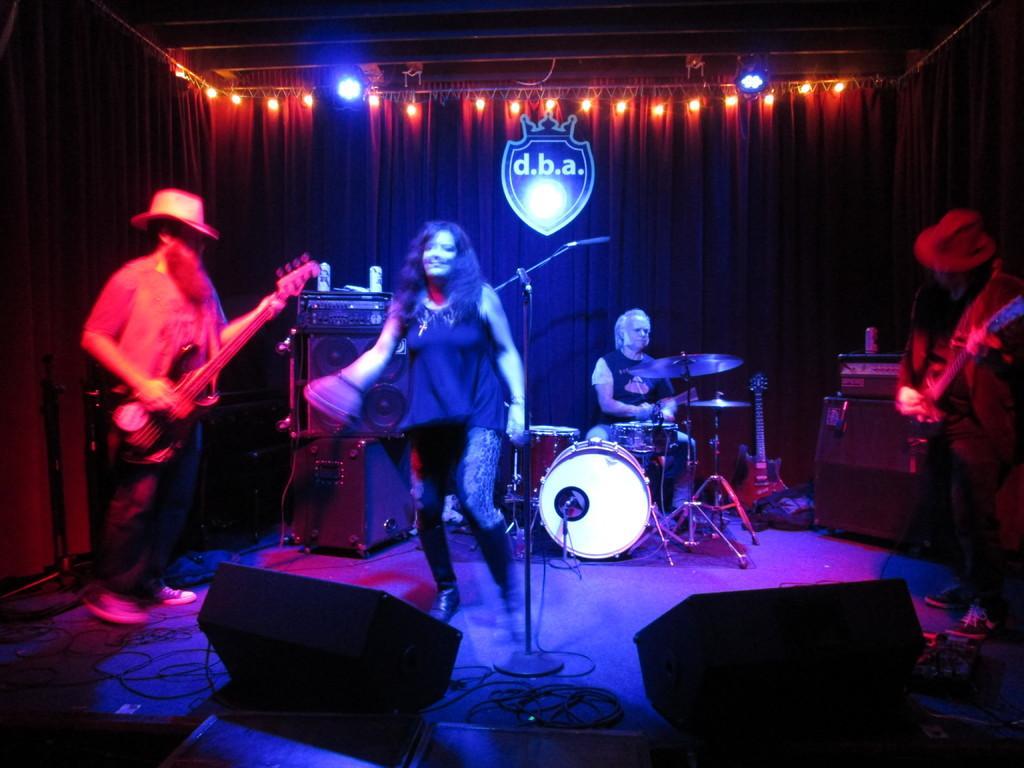Could you give a brief overview of what you see in this image? In this image i can see a group of people who are playing instruments and singing songs in front of the microphone on the stage. 